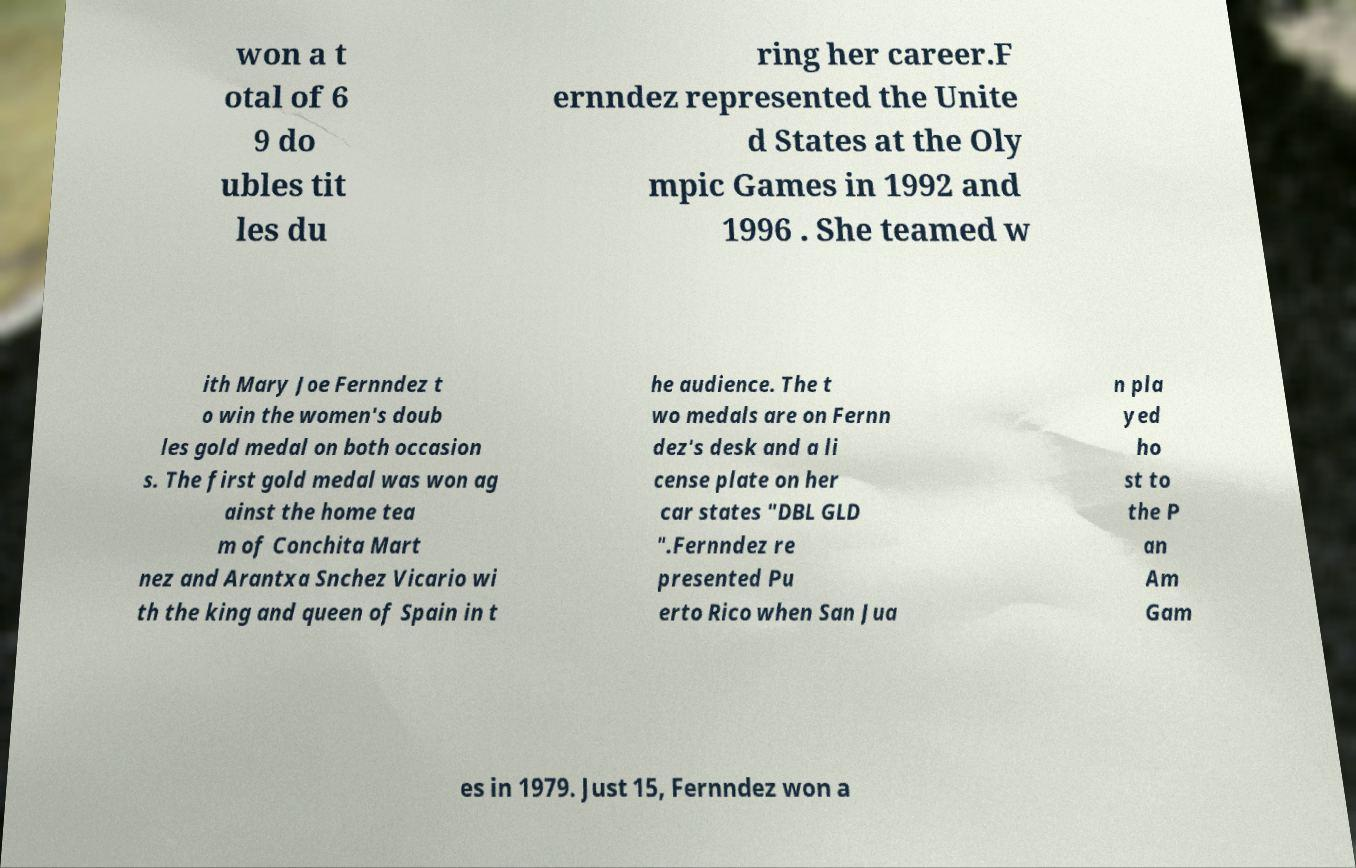Could you assist in decoding the text presented in this image and type it out clearly? won a t otal of 6 9 do ubles tit les du ring her career.F ernndez represented the Unite d States at the Oly mpic Games in 1992 and 1996 . She teamed w ith Mary Joe Fernndez t o win the women's doub les gold medal on both occasion s. The first gold medal was won ag ainst the home tea m of Conchita Mart nez and Arantxa Snchez Vicario wi th the king and queen of Spain in t he audience. The t wo medals are on Fernn dez's desk and a li cense plate on her car states "DBL GLD ".Fernndez re presented Pu erto Rico when San Jua n pla yed ho st to the P an Am Gam es in 1979. Just 15, Fernndez won a 